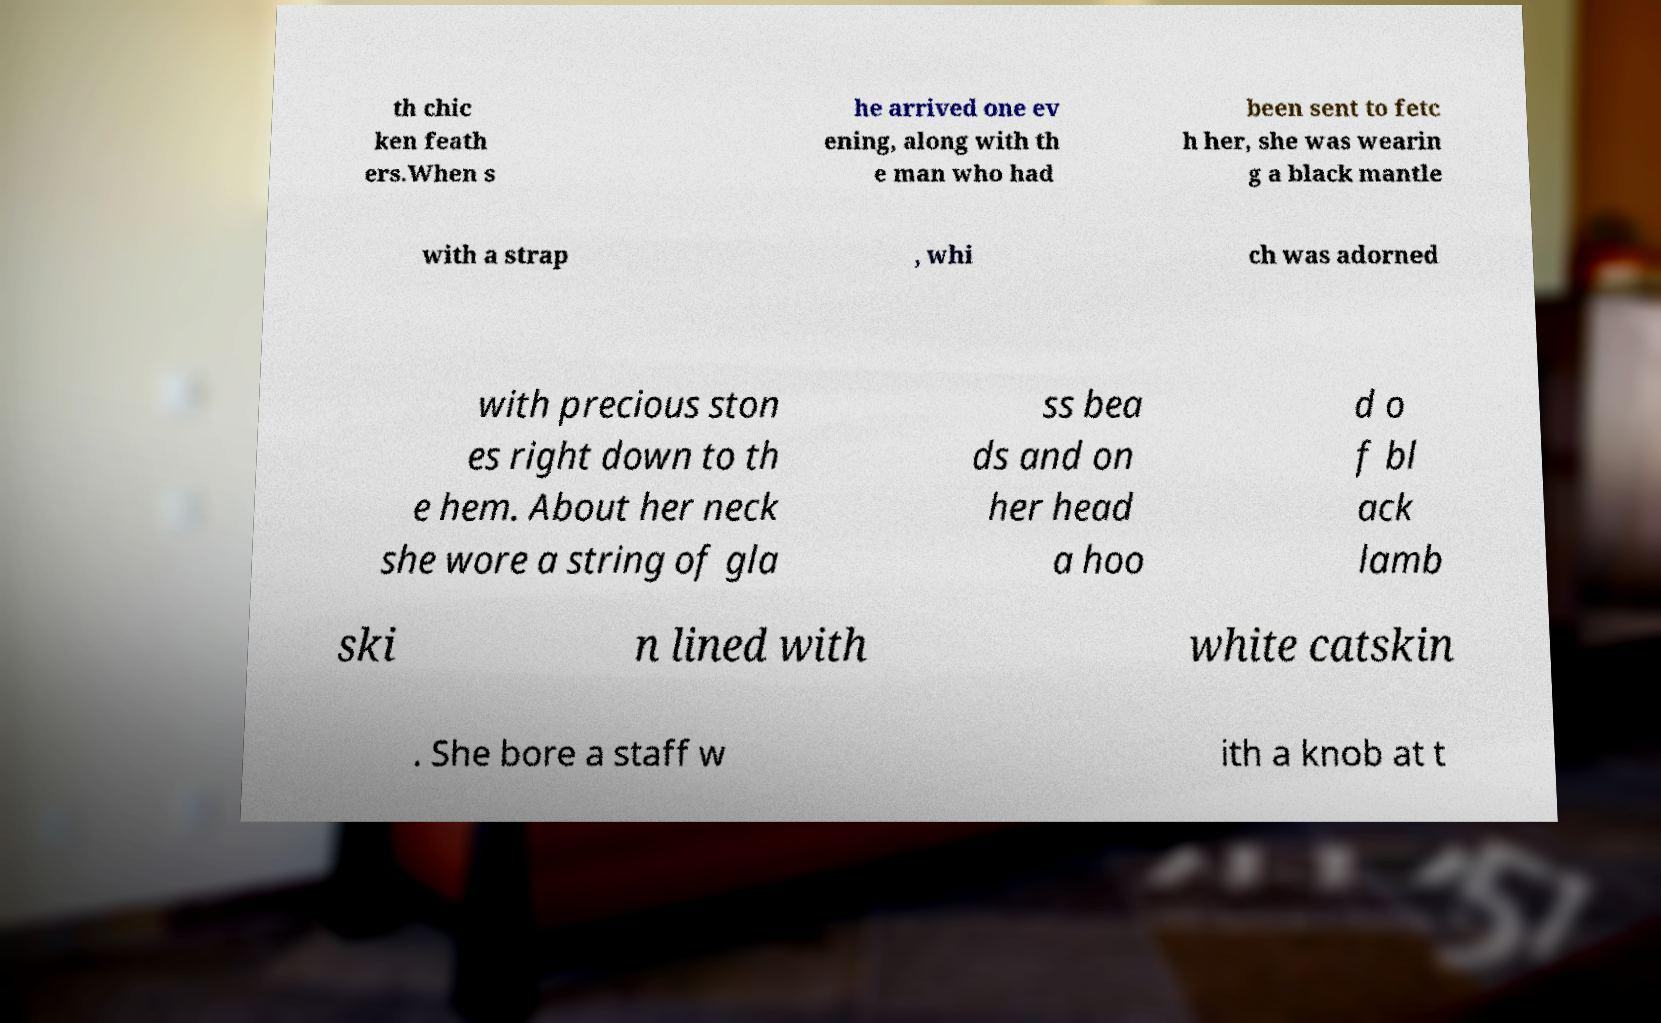Can you accurately transcribe the text from the provided image for me? th chic ken feath ers.When s he arrived one ev ening, along with th e man who had been sent to fetc h her, she was wearin g a black mantle with a strap , whi ch was adorned with precious ston es right down to th e hem. About her neck she wore a string of gla ss bea ds and on her head a hoo d o f bl ack lamb ski n lined with white catskin . She bore a staff w ith a knob at t 